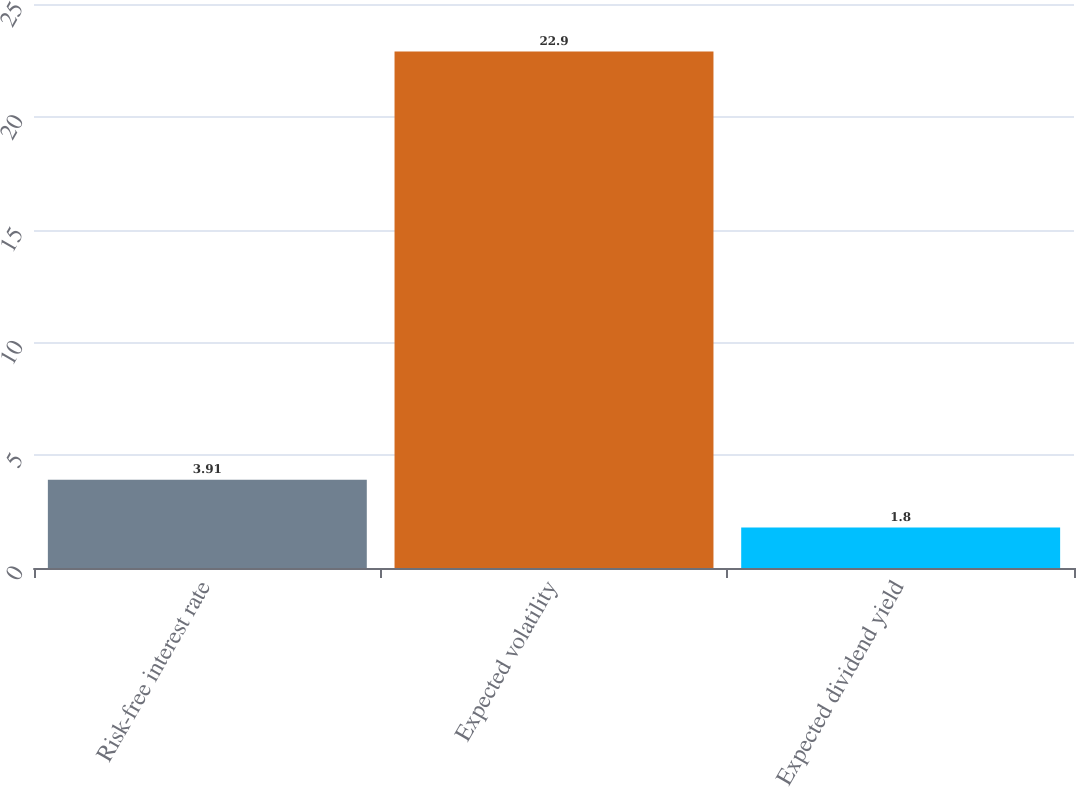<chart> <loc_0><loc_0><loc_500><loc_500><bar_chart><fcel>Risk-free interest rate<fcel>Expected volatility<fcel>Expected dividend yield<nl><fcel>3.91<fcel>22.9<fcel>1.8<nl></chart> 